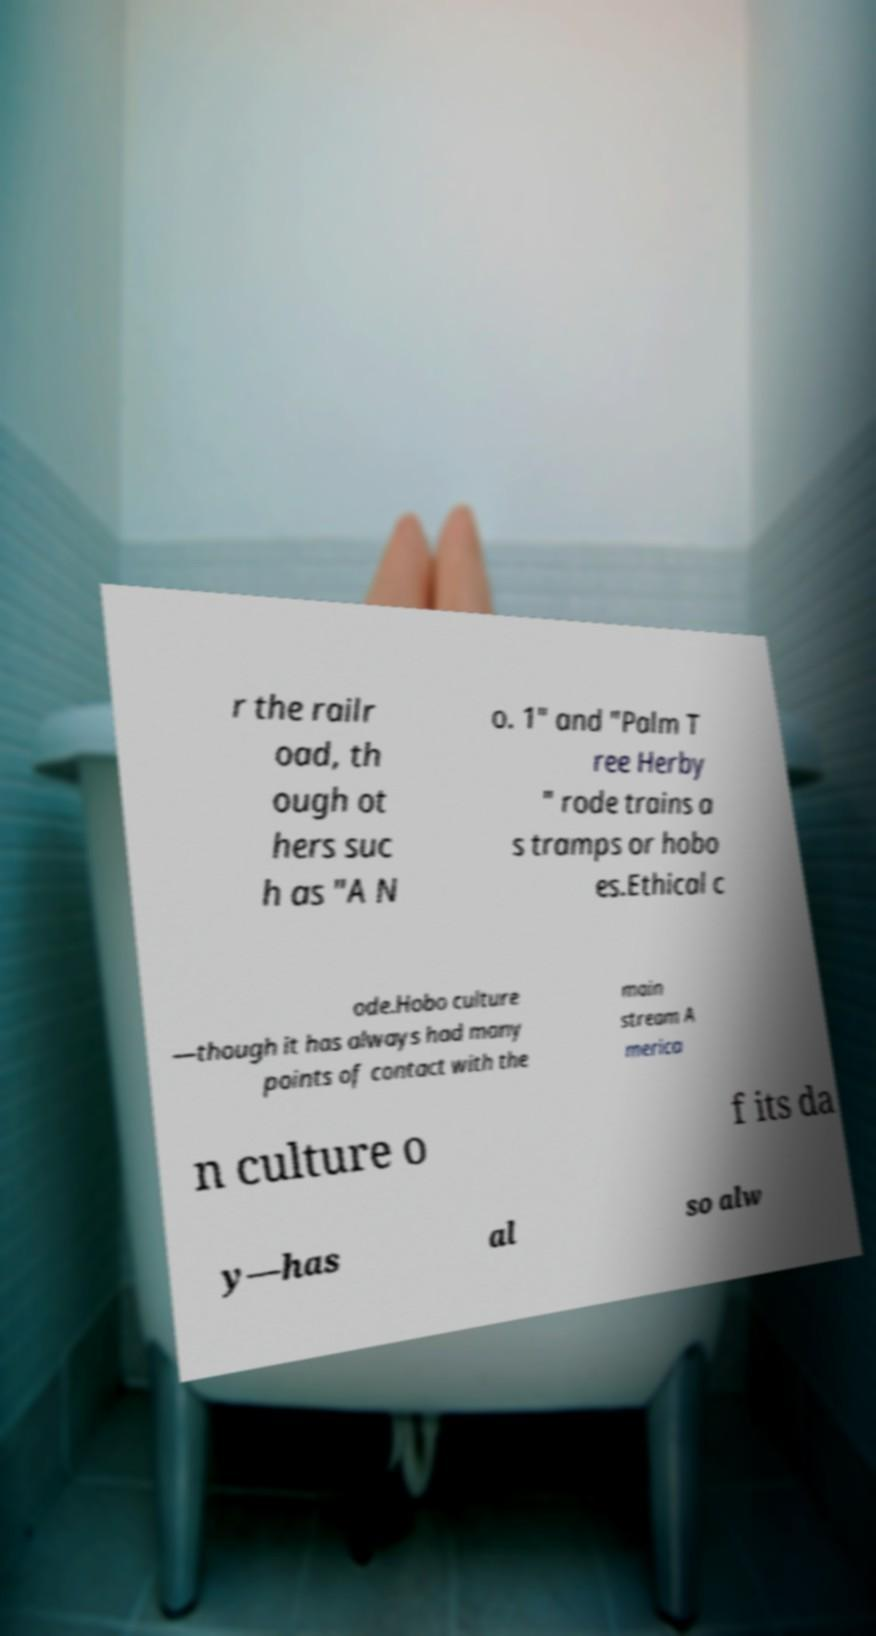Can you read and provide the text displayed in the image?This photo seems to have some interesting text. Can you extract and type it out for me? r the railr oad, th ough ot hers suc h as "A N o. 1" and "Palm T ree Herby " rode trains a s tramps or hobo es.Ethical c ode.Hobo culture —though it has always had many points of contact with the main stream A merica n culture o f its da y—has al so alw 